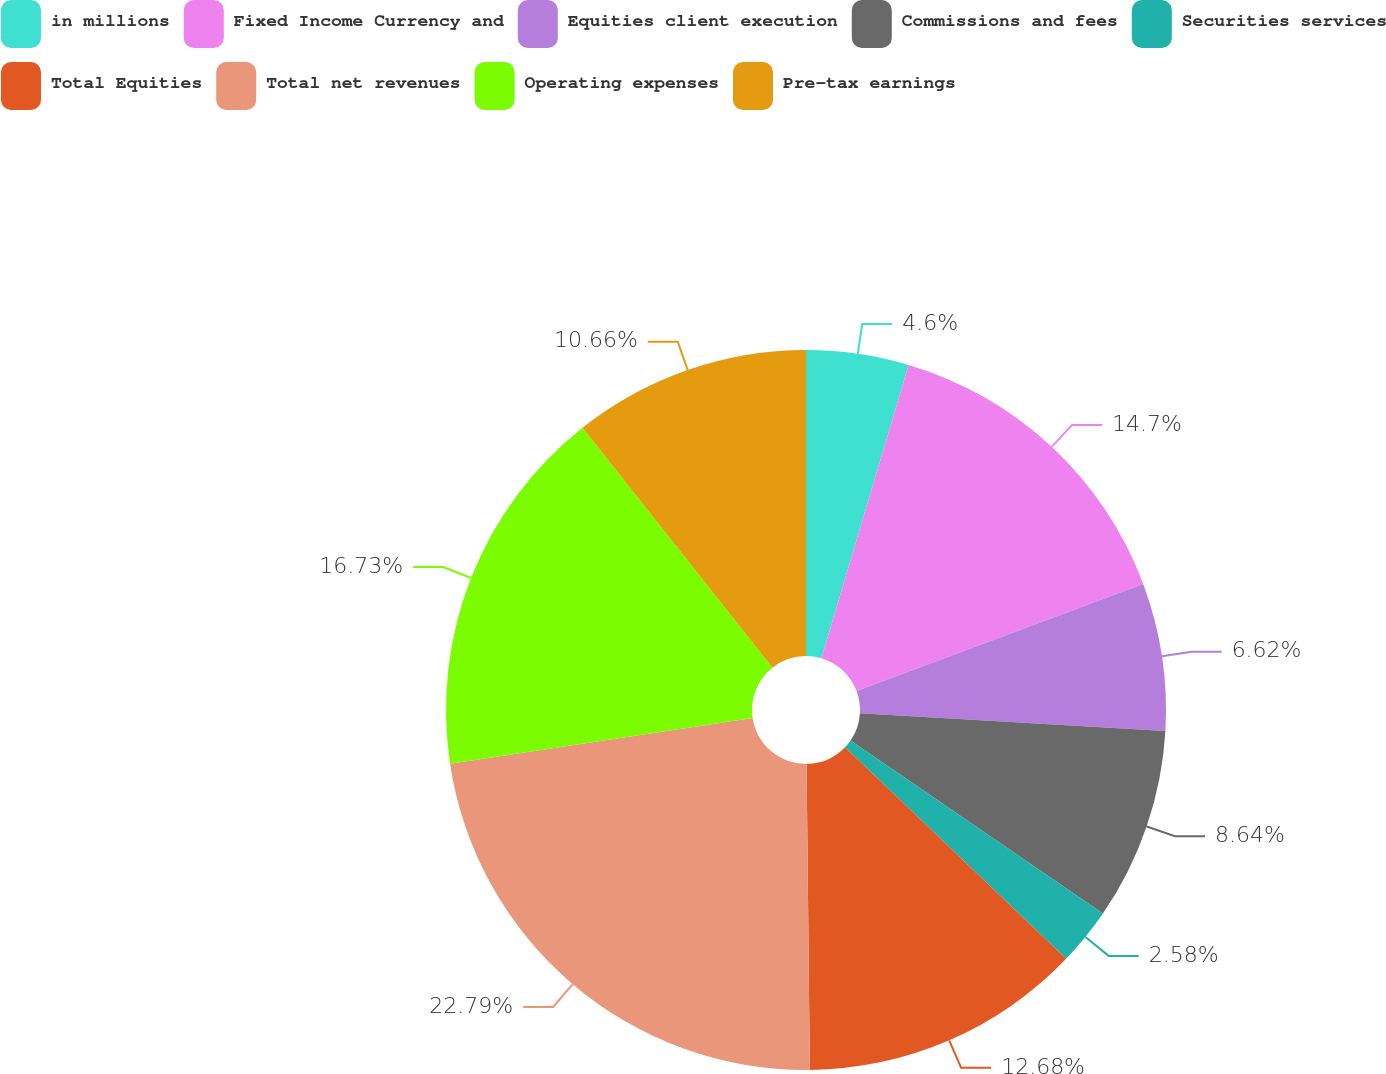<chart> <loc_0><loc_0><loc_500><loc_500><pie_chart><fcel>in millions<fcel>Fixed Income Currency and<fcel>Equities client execution<fcel>Commissions and fees<fcel>Securities services<fcel>Total Equities<fcel>Total net revenues<fcel>Operating expenses<fcel>Pre-tax earnings<nl><fcel>4.6%<fcel>14.7%<fcel>6.62%<fcel>8.64%<fcel>2.58%<fcel>12.68%<fcel>22.78%<fcel>16.72%<fcel>10.66%<nl></chart> 